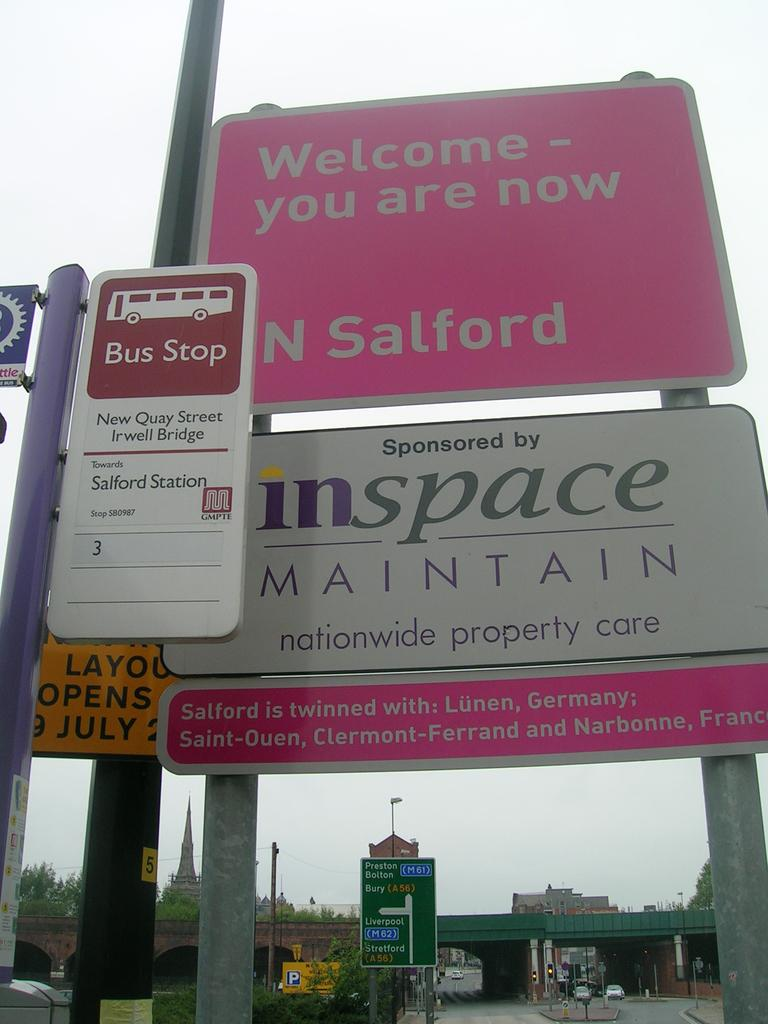<image>
Write a terse but informative summary of the picture. The sign for Salford is sponsored by inspace. 